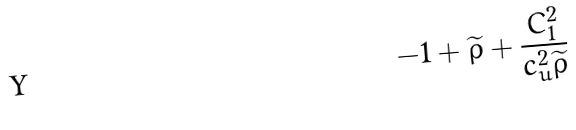<formula> <loc_0><loc_0><loc_500><loc_500>- 1 + \widetilde { \rho } + \frac { C _ { 1 } ^ { 2 } } { c _ { u } ^ { 2 } \widetilde { \rho } }</formula> 